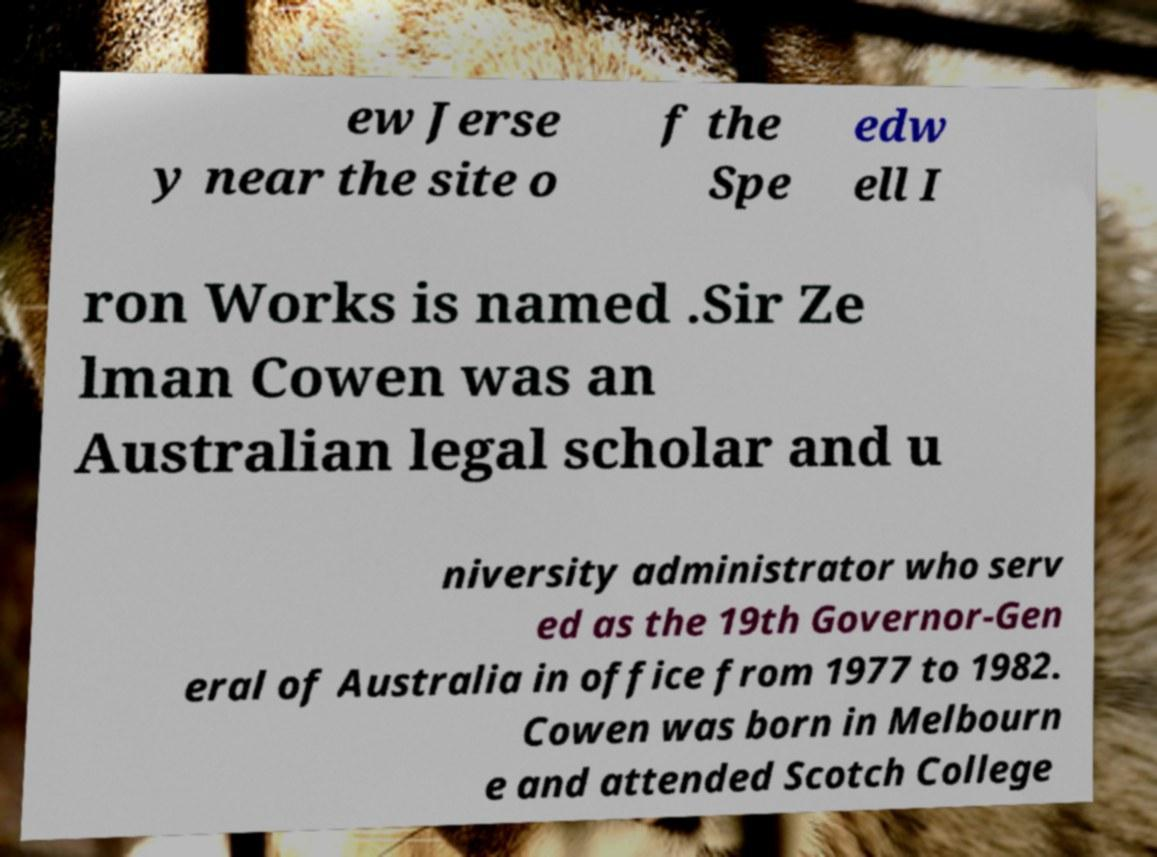Could you assist in decoding the text presented in this image and type it out clearly? ew Jerse y near the site o f the Spe edw ell I ron Works is named .Sir Ze lman Cowen was an Australian legal scholar and u niversity administrator who serv ed as the 19th Governor-Gen eral of Australia in office from 1977 to 1982. Cowen was born in Melbourn e and attended Scotch College 